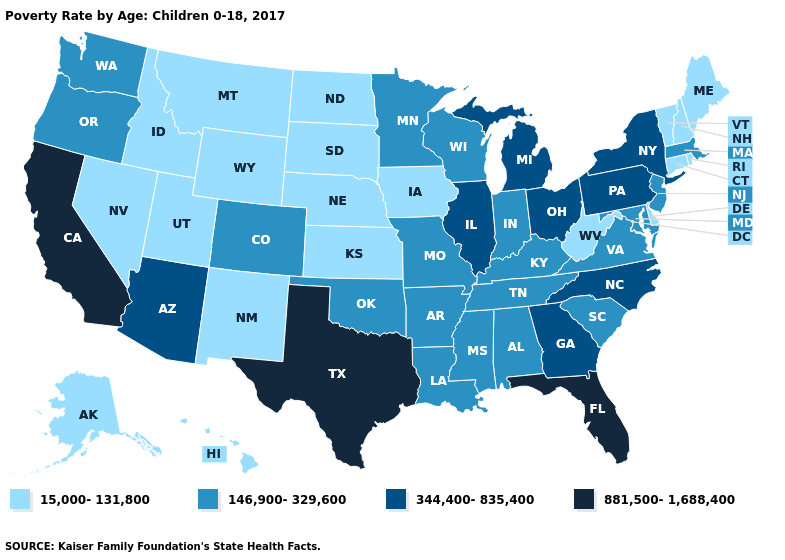What is the value of Alabama?
Be succinct. 146,900-329,600. What is the lowest value in the USA?
Be succinct. 15,000-131,800. Among the states that border Utah , does New Mexico have the highest value?
Answer briefly. No. What is the lowest value in the South?
Answer briefly. 15,000-131,800. Name the states that have a value in the range 15,000-131,800?
Be succinct. Alaska, Connecticut, Delaware, Hawaii, Idaho, Iowa, Kansas, Maine, Montana, Nebraska, Nevada, New Hampshire, New Mexico, North Dakota, Rhode Island, South Dakota, Utah, Vermont, West Virginia, Wyoming. What is the value of Washington?
Give a very brief answer. 146,900-329,600. What is the lowest value in states that border Oregon?
Give a very brief answer. 15,000-131,800. What is the value of New Mexico?
Answer briefly. 15,000-131,800. Does South Carolina have the lowest value in the USA?
Be succinct. No. Name the states that have a value in the range 15,000-131,800?
Answer briefly. Alaska, Connecticut, Delaware, Hawaii, Idaho, Iowa, Kansas, Maine, Montana, Nebraska, Nevada, New Hampshire, New Mexico, North Dakota, Rhode Island, South Dakota, Utah, Vermont, West Virginia, Wyoming. Among the states that border Missouri , which have the highest value?
Keep it brief. Illinois. Which states have the lowest value in the MidWest?
Answer briefly. Iowa, Kansas, Nebraska, North Dakota, South Dakota. Which states hav the highest value in the West?
Quick response, please. California. Does the map have missing data?
Short answer required. No. Does Massachusetts have a lower value than Colorado?
Keep it brief. No. 